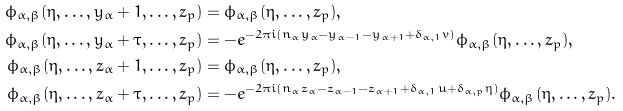Convert formula to latex. <formula><loc_0><loc_0><loc_500><loc_500>\phi _ { \alpha , \beta } ( \eta , \dots , y _ { \alpha } + 1 , \dots , z _ { p } ) & = \phi _ { \alpha , \beta } ( \eta , \dots , z _ { p } ) , \\ \phi _ { \alpha , \beta } ( \eta , \dots , y _ { \alpha } + \tau , \dots , z _ { p } ) & = - e ^ { - 2 \pi i ( n _ { \alpha } y _ { \alpha } - y _ { \alpha - 1 } - y _ { \alpha + 1 } + \delta _ { \alpha , 1 } v ) } \phi _ { \alpha , \beta } ( \eta , \dots , z _ { p } ) , \\ \phi _ { \alpha , \beta } ( \eta , \dots , z _ { \alpha } + 1 , \dots , z _ { p } ) & = \phi _ { \alpha , \beta } ( \eta , \dots , z _ { p } ) , \\ \phi _ { \alpha , \beta } ( \eta , \dots , z _ { \alpha } + \tau , \dots , z _ { p } ) & = - e ^ { - 2 \pi i ( n _ { \alpha } z _ { \alpha } - z _ { \alpha - 1 } - z _ { \alpha + 1 } + \delta _ { \alpha , 1 } u + \delta _ { \alpha , p } \eta ) } \phi _ { \alpha , \beta } ( \eta , \dots , z _ { p } ) .</formula> 